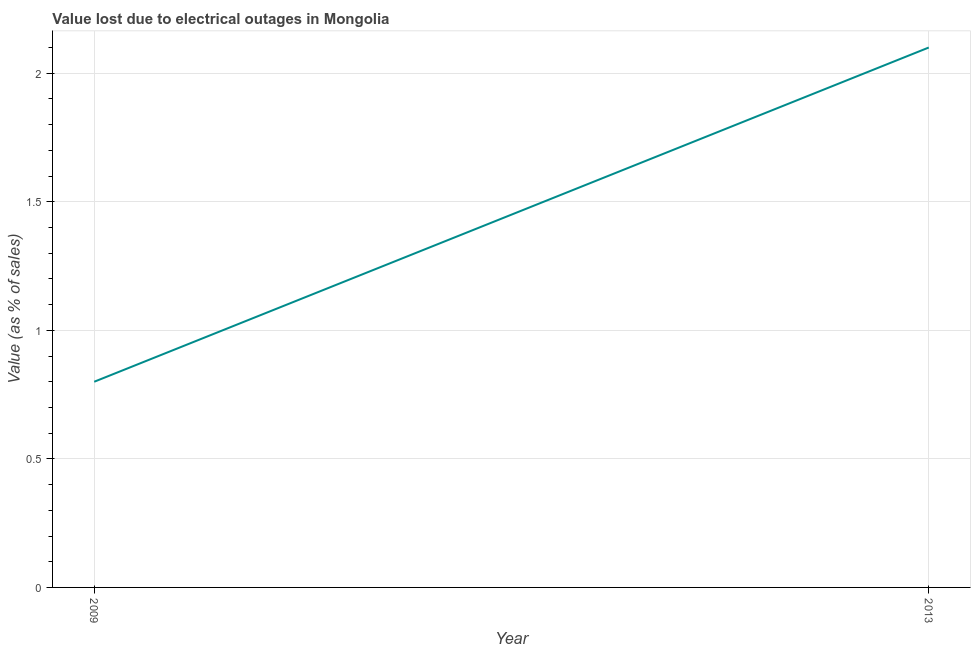What is the value lost due to electrical outages in 2009?
Your answer should be compact. 0.8. What is the sum of the value lost due to electrical outages?
Ensure brevity in your answer.  2.9. What is the difference between the value lost due to electrical outages in 2009 and 2013?
Your answer should be compact. -1.3. What is the average value lost due to electrical outages per year?
Provide a short and direct response. 1.45. What is the median value lost due to electrical outages?
Offer a very short reply. 1.45. Do a majority of the years between 2013 and 2009 (inclusive) have value lost due to electrical outages greater than 1.6 %?
Provide a succinct answer. No. What is the ratio of the value lost due to electrical outages in 2009 to that in 2013?
Offer a terse response. 0.38. In how many years, is the value lost due to electrical outages greater than the average value lost due to electrical outages taken over all years?
Ensure brevity in your answer.  1. Does the graph contain any zero values?
Give a very brief answer. No. What is the title of the graph?
Offer a very short reply. Value lost due to electrical outages in Mongolia. What is the label or title of the X-axis?
Ensure brevity in your answer.  Year. What is the label or title of the Y-axis?
Offer a terse response. Value (as % of sales). What is the difference between the Value (as % of sales) in 2009 and 2013?
Give a very brief answer. -1.3. What is the ratio of the Value (as % of sales) in 2009 to that in 2013?
Your response must be concise. 0.38. 